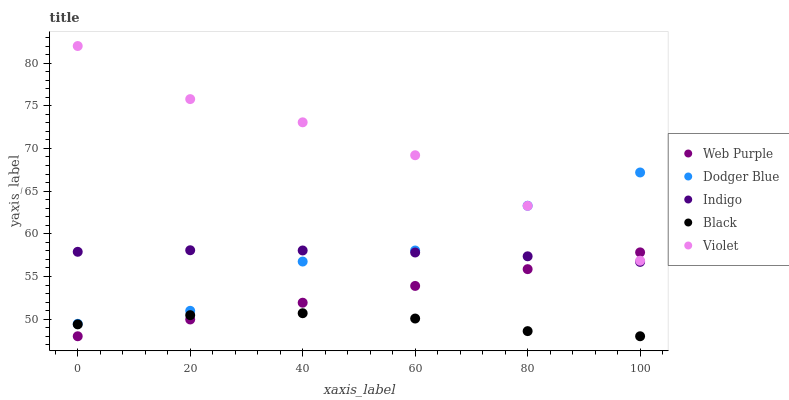Does Black have the minimum area under the curve?
Answer yes or no. Yes. Does Violet have the maximum area under the curve?
Answer yes or no. Yes. Does Web Purple have the minimum area under the curve?
Answer yes or no. No. Does Web Purple have the maximum area under the curve?
Answer yes or no. No. Is Web Purple the smoothest?
Answer yes or no. Yes. Is Dodger Blue the roughest?
Answer yes or no. Yes. Is Dodger Blue the smoothest?
Answer yes or no. No. Is Web Purple the roughest?
Answer yes or no. No. Does Web Purple have the lowest value?
Answer yes or no. Yes. Does Dodger Blue have the lowest value?
Answer yes or no. No. Does Violet have the highest value?
Answer yes or no. Yes. Does Web Purple have the highest value?
Answer yes or no. No. Is Web Purple less than Dodger Blue?
Answer yes or no. Yes. Is Dodger Blue greater than Black?
Answer yes or no. Yes. Does Web Purple intersect Indigo?
Answer yes or no. Yes. Is Web Purple less than Indigo?
Answer yes or no. No. Is Web Purple greater than Indigo?
Answer yes or no. No. Does Web Purple intersect Dodger Blue?
Answer yes or no. No. 